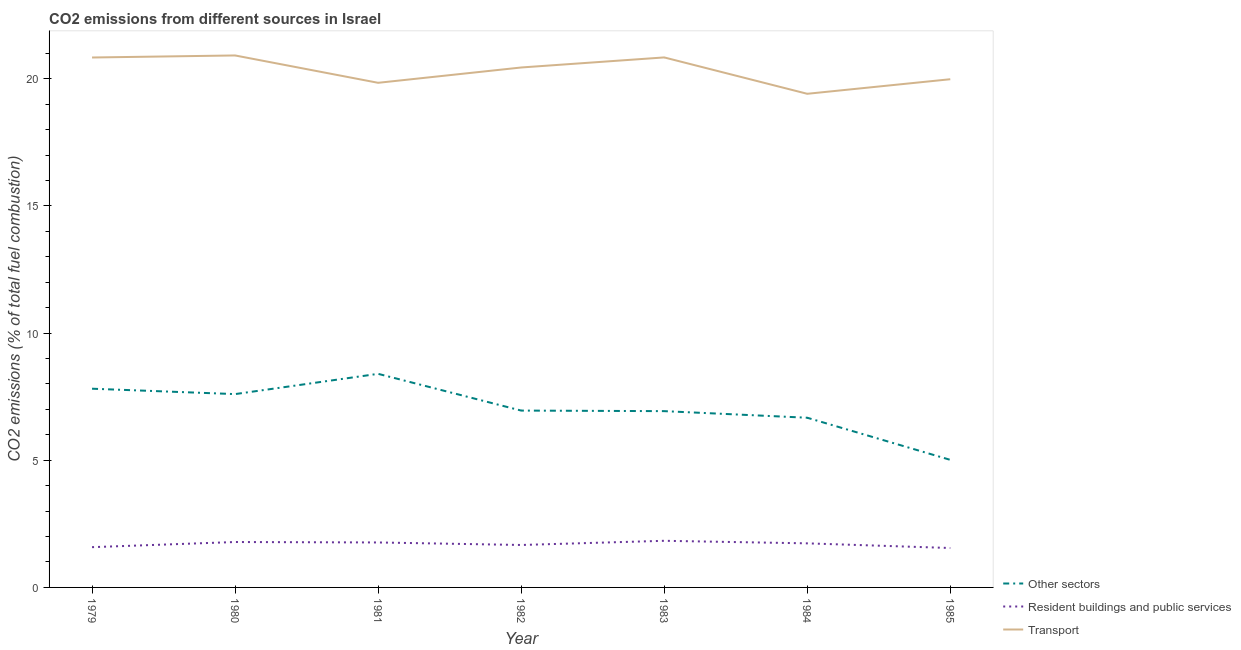Is the number of lines equal to the number of legend labels?
Your answer should be compact. Yes. What is the percentage of co2 emissions from other sectors in 1983?
Make the answer very short. 6.93. Across all years, what is the maximum percentage of co2 emissions from resident buildings and public services?
Your response must be concise. 1.83. Across all years, what is the minimum percentage of co2 emissions from transport?
Your answer should be compact. 19.41. In which year was the percentage of co2 emissions from resident buildings and public services minimum?
Provide a succinct answer. 1985. What is the total percentage of co2 emissions from other sectors in the graph?
Your response must be concise. 49.39. What is the difference between the percentage of co2 emissions from other sectors in 1979 and that in 1983?
Your answer should be very brief. 0.88. What is the difference between the percentage of co2 emissions from other sectors in 1980 and the percentage of co2 emissions from transport in 1983?
Your answer should be compact. -13.24. What is the average percentage of co2 emissions from resident buildings and public services per year?
Offer a terse response. 1.7. In the year 1983, what is the difference between the percentage of co2 emissions from other sectors and percentage of co2 emissions from transport?
Offer a terse response. -13.91. In how many years, is the percentage of co2 emissions from other sectors greater than 16 %?
Your answer should be very brief. 0. What is the ratio of the percentage of co2 emissions from resident buildings and public services in 1982 to that in 1985?
Give a very brief answer. 1.08. What is the difference between the highest and the second highest percentage of co2 emissions from resident buildings and public services?
Give a very brief answer. 0.05. What is the difference between the highest and the lowest percentage of co2 emissions from resident buildings and public services?
Your answer should be compact. 0.28. In how many years, is the percentage of co2 emissions from transport greater than the average percentage of co2 emissions from transport taken over all years?
Keep it short and to the point. 4. Is the sum of the percentage of co2 emissions from other sectors in 1979 and 1982 greater than the maximum percentage of co2 emissions from resident buildings and public services across all years?
Give a very brief answer. Yes. Is the percentage of co2 emissions from other sectors strictly greater than the percentage of co2 emissions from transport over the years?
Your answer should be compact. No. How many years are there in the graph?
Give a very brief answer. 7. Does the graph contain any zero values?
Your answer should be compact. No. Does the graph contain grids?
Make the answer very short. No. How many legend labels are there?
Your answer should be compact. 3. What is the title of the graph?
Provide a short and direct response. CO2 emissions from different sources in Israel. Does "Ores and metals" appear as one of the legend labels in the graph?
Give a very brief answer. No. What is the label or title of the Y-axis?
Your response must be concise. CO2 emissions (% of total fuel combustion). What is the CO2 emissions (% of total fuel combustion) of Other sectors in 1979?
Your answer should be compact. 7.81. What is the CO2 emissions (% of total fuel combustion) of Resident buildings and public services in 1979?
Keep it short and to the point. 1.58. What is the CO2 emissions (% of total fuel combustion) of Transport in 1979?
Give a very brief answer. 20.84. What is the CO2 emissions (% of total fuel combustion) in Other sectors in 1980?
Offer a very short reply. 7.6. What is the CO2 emissions (% of total fuel combustion) of Resident buildings and public services in 1980?
Keep it short and to the point. 1.79. What is the CO2 emissions (% of total fuel combustion) of Transport in 1980?
Your answer should be compact. 20.92. What is the CO2 emissions (% of total fuel combustion) of Other sectors in 1981?
Give a very brief answer. 8.4. What is the CO2 emissions (% of total fuel combustion) in Resident buildings and public services in 1981?
Keep it short and to the point. 1.77. What is the CO2 emissions (% of total fuel combustion) in Transport in 1981?
Your answer should be compact. 19.84. What is the CO2 emissions (% of total fuel combustion) of Other sectors in 1982?
Your answer should be compact. 6.95. What is the CO2 emissions (% of total fuel combustion) in Resident buildings and public services in 1982?
Keep it short and to the point. 1.67. What is the CO2 emissions (% of total fuel combustion) of Transport in 1982?
Your response must be concise. 20.45. What is the CO2 emissions (% of total fuel combustion) in Other sectors in 1983?
Offer a very short reply. 6.93. What is the CO2 emissions (% of total fuel combustion) in Resident buildings and public services in 1983?
Offer a terse response. 1.83. What is the CO2 emissions (% of total fuel combustion) in Transport in 1983?
Ensure brevity in your answer.  20.84. What is the CO2 emissions (% of total fuel combustion) of Other sectors in 1984?
Give a very brief answer. 6.67. What is the CO2 emissions (% of total fuel combustion) of Resident buildings and public services in 1984?
Offer a terse response. 1.73. What is the CO2 emissions (% of total fuel combustion) of Transport in 1984?
Your answer should be very brief. 19.41. What is the CO2 emissions (% of total fuel combustion) in Other sectors in 1985?
Your answer should be compact. 5.02. What is the CO2 emissions (% of total fuel combustion) in Resident buildings and public services in 1985?
Provide a short and direct response. 1.55. What is the CO2 emissions (% of total fuel combustion) in Transport in 1985?
Your answer should be compact. 19.98. Across all years, what is the maximum CO2 emissions (% of total fuel combustion) of Other sectors?
Ensure brevity in your answer.  8.4. Across all years, what is the maximum CO2 emissions (% of total fuel combustion) of Resident buildings and public services?
Your answer should be very brief. 1.83. Across all years, what is the maximum CO2 emissions (% of total fuel combustion) in Transport?
Your response must be concise. 20.92. Across all years, what is the minimum CO2 emissions (% of total fuel combustion) of Other sectors?
Provide a short and direct response. 5.02. Across all years, what is the minimum CO2 emissions (% of total fuel combustion) of Resident buildings and public services?
Offer a very short reply. 1.55. Across all years, what is the minimum CO2 emissions (% of total fuel combustion) in Transport?
Your answer should be very brief. 19.41. What is the total CO2 emissions (% of total fuel combustion) of Other sectors in the graph?
Give a very brief answer. 49.39. What is the total CO2 emissions (% of total fuel combustion) of Resident buildings and public services in the graph?
Your response must be concise. 11.92. What is the total CO2 emissions (% of total fuel combustion) of Transport in the graph?
Provide a short and direct response. 142.28. What is the difference between the CO2 emissions (% of total fuel combustion) of Other sectors in 1979 and that in 1980?
Make the answer very short. 0.21. What is the difference between the CO2 emissions (% of total fuel combustion) of Resident buildings and public services in 1979 and that in 1980?
Offer a very short reply. -0.2. What is the difference between the CO2 emissions (% of total fuel combustion) in Transport in 1979 and that in 1980?
Offer a terse response. -0.08. What is the difference between the CO2 emissions (% of total fuel combustion) of Other sectors in 1979 and that in 1981?
Provide a short and direct response. -0.58. What is the difference between the CO2 emissions (% of total fuel combustion) in Resident buildings and public services in 1979 and that in 1981?
Give a very brief answer. -0.18. What is the difference between the CO2 emissions (% of total fuel combustion) in Transport in 1979 and that in 1981?
Offer a very short reply. 0.99. What is the difference between the CO2 emissions (% of total fuel combustion) in Other sectors in 1979 and that in 1982?
Your answer should be compact. 0.86. What is the difference between the CO2 emissions (% of total fuel combustion) in Resident buildings and public services in 1979 and that in 1982?
Your answer should be very brief. -0.09. What is the difference between the CO2 emissions (% of total fuel combustion) in Transport in 1979 and that in 1982?
Keep it short and to the point. 0.39. What is the difference between the CO2 emissions (% of total fuel combustion) in Other sectors in 1979 and that in 1983?
Your response must be concise. 0.88. What is the difference between the CO2 emissions (% of total fuel combustion) of Resident buildings and public services in 1979 and that in 1983?
Provide a succinct answer. -0.25. What is the difference between the CO2 emissions (% of total fuel combustion) of Transport in 1979 and that in 1983?
Your answer should be very brief. -0. What is the difference between the CO2 emissions (% of total fuel combustion) in Other sectors in 1979 and that in 1984?
Provide a succinct answer. 1.14. What is the difference between the CO2 emissions (% of total fuel combustion) of Resident buildings and public services in 1979 and that in 1984?
Keep it short and to the point. -0.15. What is the difference between the CO2 emissions (% of total fuel combustion) of Transport in 1979 and that in 1984?
Offer a terse response. 1.43. What is the difference between the CO2 emissions (% of total fuel combustion) in Other sectors in 1979 and that in 1985?
Your answer should be very brief. 2.8. What is the difference between the CO2 emissions (% of total fuel combustion) of Resident buildings and public services in 1979 and that in 1985?
Your answer should be compact. 0.03. What is the difference between the CO2 emissions (% of total fuel combustion) in Transport in 1979 and that in 1985?
Provide a short and direct response. 0.85. What is the difference between the CO2 emissions (% of total fuel combustion) of Other sectors in 1980 and that in 1981?
Your answer should be very brief. -0.8. What is the difference between the CO2 emissions (% of total fuel combustion) of Resident buildings and public services in 1980 and that in 1981?
Your answer should be compact. 0.02. What is the difference between the CO2 emissions (% of total fuel combustion) in Transport in 1980 and that in 1981?
Make the answer very short. 1.08. What is the difference between the CO2 emissions (% of total fuel combustion) in Other sectors in 1980 and that in 1982?
Make the answer very short. 0.65. What is the difference between the CO2 emissions (% of total fuel combustion) in Resident buildings and public services in 1980 and that in 1982?
Your response must be concise. 0.12. What is the difference between the CO2 emissions (% of total fuel combustion) of Transport in 1980 and that in 1982?
Offer a very short reply. 0.47. What is the difference between the CO2 emissions (% of total fuel combustion) in Other sectors in 1980 and that in 1983?
Keep it short and to the point. 0.67. What is the difference between the CO2 emissions (% of total fuel combustion) in Resident buildings and public services in 1980 and that in 1983?
Your response must be concise. -0.05. What is the difference between the CO2 emissions (% of total fuel combustion) of Transport in 1980 and that in 1983?
Offer a terse response. 0.08. What is the difference between the CO2 emissions (% of total fuel combustion) in Other sectors in 1980 and that in 1984?
Your answer should be compact. 0.93. What is the difference between the CO2 emissions (% of total fuel combustion) of Resident buildings and public services in 1980 and that in 1984?
Keep it short and to the point. 0.05. What is the difference between the CO2 emissions (% of total fuel combustion) of Transport in 1980 and that in 1984?
Ensure brevity in your answer.  1.51. What is the difference between the CO2 emissions (% of total fuel combustion) of Other sectors in 1980 and that in 1985?
Your answer should be compact. 2.59. What is the difference between the CO2 emissions (% of total fuel combustion) in Resident buildings and public services in 1980 and that in 1985?
Your answer should be very brief. 0.24. What is the difference between the CO2 emissions (% of total fuel combustion) of Transport in 1980 and that in 1985?
Your answer should be very brief. 0.93. What is the difference between the CO2 emissions (% of total fuel combustion) of Other sectors in 1981 and that in 1982?
Make the answer very short. 1.44. What is the difference between the CO2 emissions (% of total fuel combustion) in Resident buildings and public services in 1981 and that in 1982?
Provide a succinct answer. 0.1. What is the difference between the CO2 emissions (% of total fuel combustion) of Transport in 1981 and that in 1982?
Your answer should be very brief. -0.6. What is the difference between the CO2 emissions (% of total fuel combustion) of Other sectors in 1981 and that in 1983?
Ensure brevity in your answer.  1.47. What is the difference between the CO2 emissions (% of total fuel combustion) in Resident buildings and public services in 1981 and that in 1983?
Offer a terse response. -0.07. What is the difference between the CO2 emissions (% of total fuel combustion) in Transport in 1981 and that in 1983?
Make the answer very short. -1. What is the difference between the CO2 emissions (% of total fuel combustion) in Other sectors in 1981 and that in 1984?
Give a very brief answer. 1.73. What is the difference between the CO2 emissions (% of total fuel combustion) in Resident buildings and public services in 1981 and that in 1984?
Your answer should be compact. 0.04. What is the difference between the CO2 emissions (% of total fuel combustion) in Transport in 1981 and that in 1984?
Your answer should be very brief. 0.43. What is the difference between the CO2 emissions (% of total fuel combustion) of Other sectors in 1981 and that in 1985?
Ensure brevity in your answer.  3.38. What is the difference between the CO2 emissions (% of total fuel combustion) of Resident buildings and public services in 1981 and that in 1985?
Your answer should be compact. 0.22. What is the difference between the CO2 emissions (% of total fuel combustion) in Transport in 1981 and that in 1985?
Keep it short and to the point. -0.14. What is the difference between the CO2 emissions (% of total fuel combustion) in Other sectors in 1982 and that in 1983?
Offer a very short reply. 0.02. What is the difference between the CO2 emissions (% of total fuel combustion) in Resident buildings and public services in 1982 and that in 1983?
Offer a terse response. -0.16. What is the difference between the CO2 emissions (% of total fuel combustion) of Transport in 1982 and that in 1983?
Your response must be concise. -0.4. What is the difference between the CO2 emissions (% of total fuel combustion) in Other sectors in 1982 and that in 1984?
Your response must be concise. 0.28. What is the difference between the CO2 emissions (% of total fuel combustion) of Resident buildings and public services in 1982 and that in 1984?
Provide a succinct answer. -0.06. What is the difference between the CO2 emissions (% of total fuel combustion) of Transport in 1982 and that in 1984?
Provide a succinct answer. 1.03. What is the difference between the CO2 emissions (% of total fuel combustion) in Other sectors in 1982 and that in 1985?
Offer a very short reply. 1.94. What is the difference between the CO2 emissions (% of total fuel combustion) in Resident buildings and public services in 1982 and that in 1985?
Your response must be concise. 0.12. What is the difference between the CO2 emissions (% of total fuel combustion) of Transport in 1982 and that in 1985?
Make the answer very short. 0.46. What is the difference between the CO2 emissions (% of total fuel combustion) in Other sectors in 1983 and that in 1984?
Offer a very short reply. 0.26. What is the difference between the CO2 emissions (% of total fuel combustion) in Resident buildings and public services in 1983 and that in 1984?
Give a very brief answer. 0.1. What is the difference between the CO2 emissions (% of total fuel combustion) in Transport in 1983 and that in 1984?
Your response must be concise. 1.43. What is the difference between the CO2 emissions (% of total fuel combustion) in Other sectors in 1983 and that in 1985?
Offer a very short reply. 1.92. What is the difference between the CO2 emissions (% of total fuel combustion) of Resident buildings and public services in 1983 and that in 1985?
Your answer should be very brief. 0.28. What is the difference between the CO2 emissions (% of total fuel combustion) in Transport in 1983 and that in 1985?
Offer a very short reply. 0.86. What is the difference between the CO2 emissions (% of total fuel combustion) in Other sectors in 1984 and that in 1985?
Give a very brief answer. 1.66. What is the difference between the CO2 emissions (% of total fuel combustion) of Resident buildings and public services in 1984 and that in 1985?
Your answer should be compact. 0.18. What is the difference between the CO2 emissions (% of total fuel combustion) in Transport in 1984 and that in 1985?
Provide a succinct answer. -0.57. What is the difference between the CO2 emissions (% of total fuel combustion) of Other sectors in 1979 and the CO2 emissions (% of total fuel combustion) of Resident buildings and public services in 1980?
Your answer should be very brief. 6.03. What is the difference between the CO2 emissions (% of total fuel combustion) of Other sectors in 1979 and the CO2 emissions (% of total fuel combustion) of Transport in 1980?
Make the answer very short. -13.1. What is the difference between the CO2 emissions (% of total fuel combustion) in Resident buildings and public services in 1979 and the CO2 emissions (% of total fuel combustion) in Transport in 1980?
Ensure brevity in your answer.  -19.34. What is the difference between the CO2 emissions (% of total fuel combustion) of Other sectors in 1979 and the CO2 emissions (% of total fuel combustion) of Resident buildings and public services in 1981?
Make the answer very short. 6.05. What is the difference between the CO2 emissions (% of total fuel combustion) of Other sectors in 1979 and the CO2 emissions (% of total fuel combustion) of Transport in 1981?
Ensure brevity in your answer.  -12.03. What is the difference between the CO2 emissions (% of total fuel combustion) of Resident buildings and public services in 1979 and the CO2 emissions (% of total fuel combustion) of Transport in 1981?
Your answer should be compact. -18.26. What is the difference between the CO2 emissions (% of total fuel combustion) of Other sectors in 1979 and the CO2 emissions (% of total fuel combustion) of Resident buildings and public services in 1982?
Provide a short and direct response. 6.15. What is the difference between the CO2 emissions (% of total fuel combustion) of Other sectors in 1979 and the CO2 emissions (% of total fuel combustion) of Transport in 1982?
Offer a terse response. -12.63. What is the difference between the CO2 emissions (% of total fuel combustion) in Resident buildings and public services in 1979 and the CO2 emissions (% of total fuel combustion) in Transport in 1982?
Keep it short and to the point. -18.86. What is the difference between the CO2 emissions (% of total fuel combustion) in Other sectors in 1979 and the CO2 emissions (% of total fuel combustion) in Resident buildings and public services in 1983?
Provide a succinct answer. 5.98. What is the difference between the CO2 emissions (% of total fuel combustion) of Other sectors in 1979 and the CO2 emissions (% of total fuel combustion) of Transport in 1983?
Offer a terse response. -13.03. What is the difference between the CO2 emissions (% of total fuel combustion) in Resident buildings and public services in 1979 and the CO2 emissions (% of total fuel combustion) in Transport in 1983?
Your answer should be very brief. -19.26. What is the difference between the CO2 emissions (% of total fuel combustion) of Other sectors in 1979 and the CO2 emissions (% of total fuel combustion) of Resident buildings and public services in 1984?
Your response must be concise. 6.08. What is the difference between the CO2 emissions (% of total fuel combustion) of Other sectors in 1979 and the CO2 emissions (% of total fuel combustion) of Transport in 1984?
Provide a short and direct response. -11.6. What is the difference between the CO2 emissions (% of total fuel combustion) in Resident buildings and public services in 1979 and the CO2 emissions (% of total fuel combustion) in Transport in 1984?
Provide a short and direct response. -17.83. What is the difference between the CO2 emissions (% of total fuel combustion) of Other sectors in 1979 and the CO2 emissions (% of total fuel combustion) of Resident buildings and public services in 1985?
Your answer should be very brief. 6.26. What is the difference between the CO2 emissions (% of total fuel combustion) in Other sectors in 1979 and the CO2 emissions (% of total fuel combustion) in Transport in 1985?
Keep it short and to the point. -12.17. What is the difference between the CO2 emissions (% of total fuel combustion) in Resident buildings and public services in 1979 and the CO2 emissions (% of total fuel combustion) in Transport in 1985?
Provide a short and direct response. -18.4. What is the difference between the CO2 emissions (% of total fuel combustion) of Other sectors in 1980 and the CO2 emissions (% of total fuel combustion) of Resident buildings and public services in 1981?
Provide a short and direct response. 5.83. What is the difference between the CO2 emissions (% of total fuel combustion) in Other sectors in 1980 and the CO2 emissions (% of total fuel combustion) in Transport in 1981?
Give a very brief answer. -12.24. What is the difference between the CO2 emissions (% of total fuel combustion) in Resident buildings and public services in 1980 and the CO2 emissions (% of total fuel combustion) in Transport in 1981?
Offer a terse response. -18.06. What is the difference between the CO2 emissions (% of total fuel combustion) in Other sectors in 1980 and the CO2 emissions (% of total fuel combustion) in Resident buildings and public services in 1982?
Give a very brief answer. 5.93. What is the difference between the CO2 emissions (% of total fuel combustion) of Other sectors in 1980 and the CO2 emissions (% of total fuel combustion) of Transport in 1982?
Ensure brevity in your answer.  -12.84. What is the difference between the CO2 emissions (% of total fuel combustion) in Resident buildings and public services in 1980 and the CO2 emissions (% of total fuel combustion) in Transport in 1982?
Offer a very short reply. -18.66. What is the difference between the CO2 emissions (% of total fuel combustion) of Other sectors in 1980 and the CO2 emissions (% of total fuel combustion) of Resident buildings and public services in 1983?
Offer a terse response. 5.77. What is the difference between the CO2 emissions (% of total fuel combustion) of Other sectors in 1980 and the CO2 emissions (% of total fuel combustion) of Transport in 1983?
Give a very brief answer. -13.24. What is the difference between the CO2 emissions (% of total fuel combustion) of Resident buildings and public services in 1980 and the CO2 emissions (% of total fuel combustion) of Transport in 1983?
Ensure brevity in your answer.  -19.06. What is the difference between the CO2 emissions (% of total fuel combustion) of Other sectors in 1980 and the CO2 emissions (% of total fuel combustion) of Resident buildings and public services in 1984?
Your response must be concise. 5.87. What is the difference between the CO2 emissions (% of total fuel combustion) of Other sectors in 1980 and the CO2 emissions (% of total fuel combustion) of Transport in 1984?
Keep it short and to the point. -11.81. What is the difference between the CO2 emissions (% of total fuel combustion) in Resident buildings and public services in 1980 and the CO2 emissions (% of total fuel combustion) in Transport in 1984?
Ensure brevity in your answer.  -17.62. What is the difference between the CO2 emissions (% of total fuel combustion) in Other sectors in 1980 and the CO2 emissions (% of total fuel combustion) in Resident buildings and public services in 1985?
Offer a terse response. 6.05. What is the difference between the CO2 emissions (% of total fuel combustion) of Other sectors in 1980 and the CO2 emissions (% of total fuel combustion) of Transport in 1985?
Your answer should be very brief. -12.38. What is the difference between the CO2 emissions (% of total fuel combustion) in Resident buildings and public services in 1980 and the CO2 emissions (% of total fuel combustion) in Transport in 1985?
Provide a short and direct response. -18.2. What is the difference between the CO2 emissions (% of total fuel combustion) of Other sectors in 1981 and the CO2 emissions (% of total fuel combustion) of Resident buildings and public services in 1982?
Make the answer very short. 6.73. What is the difference between the CO2 emissions (% of total fuel combustion) in Other sectors in 1981 and the CO2 emissions (% of total fuel combustion) in Transport in 1982?
Provide a succinct answer. -12.05. What is the difference between the CO2 emissions (% of total fuel combustion) of Resident buildings and public services in 1981 and the CO2 emissions (% of total fuel combustion) of Transport in 1982?
Provide a short and direct response. -18.68. What is the difference between the CO2 emissions (% of total fuel combustion) in Other sectors in 1981 and the CO2 emissions (% of total fuel combustion) in Resident buildings and public services in 1983?
Your response must be concise. 6.57. What is the difference between the CO2 emissions (% of total fuel combustion) of Other sectors in 1981 and the CO2 emissions (% of total fuel combustion) of Transport in 1983?
Your response must be concise. -12.44. What is the difference between the CO2 emissions (% of total fuel combustion) of Resident buildings and public services in 1981 and the CO2 emissions (% of total fuel combustion) of Transport in 1983?
Provide a succinct answer. -19.07. What is the difference between the CO2 emissions (% of total fuel combustion) of Other sectors in 1981 and the CO2 emissions (% of total fuel combustion) of Resident buildings and public services in 1984?
Keep it short and to the point. 6.67. What is the difference between the CO2 emissions (% of total fuel combustion) of Other sectors in 1981 and the CO2 emissions (% of total fuel combustion) of Transport in 1984?
Your answer should be very brief. -11.01. What is the difference between the CO2 emissions (% of total fuel combustion) in Resident buildings and public services in 1981 and the CO2 emissions (% of total fuel combustion) in Transport in 1984?
Offer a terse response. -17.64. What is the difference between the CO2 emissions (% of total fuel combustion) in Other sectors in 1981 and the CO2 emissions (% of total fuel combustion) in Resident buildings and public services in 1985?
Your answer should be compact. 6.85. What is the difference between the CO2 emissions (% of total fuel combustion) in Other sectors in 1981 and the CO2 emissions (% of total fuel combustion) in Transport in 1985?
Your response must be concise. -11.58. What is the difference between the CO2 emissions (% of total fuel combustion) of Resident buildings and public services in 1981 and the CO2 emissions (% of total fuel combustion) of Transport in 1985?
Your answer should be compact. -18.22. What is the difference between the CO2 emissions (% of total fuel combustion) of Other sectors in 1982 and the CO2 emissions (% of total fuel combustion) of Resident buildings and public services in 1983?
Make the answer very short. 5.12. What is the difference between the CO2 emissions (% of total fuel combustion) of Other sectors in 1982 and the CO2 emissions (% of total fuel combustion) of Transport in 1983?
Ensure brevity in your answer.  -13.89. What is the difference between the CO2 emissions (% of total fuel combustion) in Resident buildings and public services in 1982 and the CO2 emissions (% of total fuel combustion) in Transport in 1983?
Keep it short and to the point. -19.17. What is the difference between the CO2 emissions (% of total fuel combustion) of Other sectors in 1982 and the CO2 emissions (% of total fuel combustion) of Resident buildings and public services in 1984?
Provide a short and direct response. 5.22. What is the difference between the CO2 emissions (% of total fuel combustion) in Other sectors in 1982 and the CO2 emissions (% of total fuel combustion) in Transport in 1984?
Your answer should be compact. -12.46. What is the difference between the CO2 emissions (% of total fuel combustion) of Resident buildings and public services in 1982 and the CO2 emissions (% of total fuel combustion) of Transport in 1984?
Your answer should be very brief. -17.74. What is the difference between the CO2 emissions (% of total fuel combustion) in Other sectors in 1982 and the CO2 emissions (% of total fuel combustion) in Resident buildings and public services in 1985?
Offer a terse response. 5.4. What is the difference between the CO2 emissions (% of total fuel combustion) of Other sectors in 1982 and the CO2 emissions (% of total fuel combustion) of Transport in 1985?
Offer a terse response. -13.03. What is the difference between the CO2 emissions (% of total fuel combustion) in Resident buildings and public services in 1982 and the CO2 emissions (% of total fuel combustion) in Transport in 1985?
Your answer should be compact. -18.31. What is the difference between the CO2 emissions (% of total fuel combustion) in Other sectors in 1983 and the CO2 emissions (% of total fuel combustion) in Resident buildings and public services in 1984?
Your answer should be very brief. 5.2. What is the difference between the CO2 emissions (% of total fuel combustion) of Other sectors in 1983 and the CO2 emissions (% of total fuel combustion) of Transport in 1984?
Your answer should be compact. -12.48. What is the difference between the CO2 emissions (% of total fuel combustion) of Resident buildings and public services in 1983 and the CO2 emissions (% of total fuel combustion) of Transport in 1984?
Make the answer very short. -17.58. What is the difference between the CO2 emissions (% of total fuel combustion) of Other sectors in 1983 and the CO2 emissions (% of total fuel combustion) of Resident buildings and public services in 1985?
Keep it short and to the point. 5.38. What is the difference between the CO2 emissions (% of total fuel combustion) in Other sectors in 1983 and the CO2 emissions (% of total fuel combustion) in Transport in 1985?
Your answer should be compact. -13.05. What is the difference between the CO2 emissions (% of total fuel combustion) in Resident buildings and public services in 1983 and the CO2 emissions (% of total fuel combustion) in Transport in 1985?
Offer a very short reply. -18.15. What is the difference between the CO2 emissions (% of total fuel combustion) in Other sectors in 1984 and the CO2 emissions (% of total fuel combustion) in Resident buildings and public services in 1985?
Give a very brief answer. 5.12. What is the difference between the CO2 emissions (% of total fuel combustion) in Other sectors in 1984 and the CO2 emissions (% of total fuel combustion) in Transport in 1985?
Your response must be concise. -13.31. What is the difference between the CO2 emissions (% of total fuel combustion) of Resident buildings and public services in 1984 and the CO2 emissions (% of total fuel combustion) of Transport in 1985?
Provide a short and direct response. -18.25. What is the average CO2 emissions (% of total fuel combustion) in Other sectors per year?
Offer a very short reply. 7.06. What is the average CO2 emissions (% of total fuel combustion) in Resident buildings and public services per year?
Keep it short and to the point. 1.7. What is the average CO2 emissions (% of total fuel combustion) of Transport per year?
Make the answer very short. 20.33. In the year 1979, what is the difference between the CO2 emissions (% of total fuel combustion) in Other sectors and CO2 emissions (% of total fuel combustion) in Resident buildings and public services?
Ensure brevity in your answer.  6.23. In the year 1979, what is the difference between the CO2 emissions (% of total fuel combustion) in Other sectors and CO2 emissions (% of total fuel combustion) in Transport?
Make the answer very short. -13.02. In the year 1979, what is the difference between the CO2 emissions (% of total fuel combustion) of Resident buildings and public services and CO2 emissions (% of total fuel combustion) of Transport?
Your answer should be very brief. -19.25. In the year 1980, what is the difference between the CO2 emissions (% of total fuel combustion) in Other sectors and CO2 emissions (% of total fuel combustion) in Resident buildings and public services?
Keep it short and to the point. 5.82. In the year 1980, what is the difference between the CO2 emissions (% of total fuel combustion) in Other sectors and CO2 emissions (% of total fuel combustion) in Transport?
Provide a succinct answer. -13.32. In the year 1980, what is the difference between the CO2 emissions (% of total fuel combustion) in Resident buildings and public services and CO2 emissions (% of total fuel combustion) in Transport?
Your response must be concise. -19.13. In the year 1981, what is the difference between the CO2 emissions (% of total fuel combustion) of Other sectors and CO2 emissions (% of total fuel combustion) of Resident buildings and public services?
Ensure brevity in your answer.  6.63. In the year 1981, what is the difference between the CO2 emissions (% of total fuel combustion) of Other sectors and CO2 emissions (% of total fuel combustion) of Transport?
Offer a very short reply. -11.44. In the year 1981, what is the difference between the CO2 emissions (% of total fuel combustion) of Resident buildings and public services and CO2 emissions (% of total fuel combustion) of Transport?
Provide a succinct answer. -18.07. In the year 1982, what is the difference between the CO2 emissions (% of total fuel combustion) of Other sectors and CO2 emissions (% of total fuel combustion) of Resident buildings and public services?
Your answer should be very brief. 5.29. In the year 1982, what is the difference between the CO2 emissions (% of total fuel combustion) in Other sectors and CO2 emissions (% of total fuel combustion) in Transport?
Your response must be concise. -13.49. In the year 1982, what is the difference between the CO2 emissions (% of total fuel combustion) of Resident buildings and public services and CO2 emissions (% of total fuel combustion) of Transport?
Provide a succinct answer. -18.78. In the year 1983, what is the difference between the CO2 emissions (% of total fuel combustion) in Other sectors and CO2 emissions (% of total fuel combustion) in Resident buildings and public services?
Give a very brief answer. 5.1. In the year 1983, what is the difference between the CO2 emissions (% of total fuel combustion) in Other sectors and CO2 emissions (% of total fuel combustion) in Transport?
Ensure brevity in your answer.  -13.91. In the year 1983, what is the difference between the CO2 emissions (% of total fuel combustion) in Resident buildings and public services and CO2 emissions (% of total fuel combustion) in Transport?
Make the answer very short. -19.01. In the year 1984, what is the difference between the CO2 emissions (% of total fuel combustion) in Other sectors and CO2 emissions (% of total fuel combustion) in Resident buildings and public services?
Make the answer very short. 4.94. In the year 1984, what is the difference between the CO2 emissions (% of total fuel combustion) in Other sectors and CO2 emissions (% of total fuel combustion) in Transport?
Offer a very short reply. -12.74. In the year 1984, what is the difference between the CO2 emissions (% of total fuel combustion) of Resident buildings and public services and CO2 emissions (% of total fuel combustion) of Transport?
Provide a succinct answer. -17.68. In the year 1985, what is the difference between the CO2 emissions (% of total fuel combustion) of Other sectors and CO2 emissions (% of total fuel combustion) of Resident buildings and public services?
Provide a short and direct response. 3.47. In the year 1985, what is the difference between the CO2 emissions (% of total fuel combustion) in Other sectors and CO2 emissions (% of total fuel combustion) in Transport?
Provide a short and direct response. -14.97. In the year 1985, what is the difference between the CO2 emissions (% of total fuel combustion) of Resident buildings and public services and CO2 emissions (% of total fuel combustion) of Transport?
Ensure brevity in your answer.  -18.43. What is the ratio of the CO2 emissions (% of total fuel combustion) in Other sectors in 1979 to that in 1980?
Offer a very short reply. 1.03. What is the ratio of the CO2 emissions (% of total fuel combustion) in Resident buildings and public services in 1979 to that in 1980?
Offer a very short reply. 0.89. What is the ratio of the CO2 emissions (% of total fuel combustion) of Transport in 1979 to that in 1980?
Make the answer very short. 1. What is the ratio of the CO2 emissions (% of total fuel combustion) of Other sectors in 1979 to that in 1981?
Your response must be concise. 0.93. What is the ratio of the CO2 emissions (% of total fuel combustion) of Resident buildings and public services in 1979 to that in 1981?
Keep it short and to the point. 0.9. What is the ratio of the CO2 emissions (% of total fuel combustion) in Transport in 1979 to that in 1981?
Offer a very short reply. 1.05. What is the ratio of the CO2 emissions (% of total fuel combustion) of Other sectors in 1979 to that in 1982?
Offer a very short reply. 1.12. What is the ratio of the CO2 emissions (% of total fuel combustion) of Resident buildings and public services in 1979 to that in 1982?
Make the answer very short. 0.95. What is the ratio of the CO2 emissions (% of total fuel combustion) of Transport in 1979 to that in 1982?
Keep it short and to the point. 1.02. What is the ratio of the CO2 emissions (% of total fuel combustion) in Other sectors in 1979 to that in 1983?
Make the answer very short. 1.13. What is the ratio of the CO2 emissions (% of total fuel combustion) of Resident buildings and public services in 1979 to that in 1983?
Offer a terse response. 0.86. What is the ratio of the CO2 emissions (% of total fuel combustion) of Other sectors in 1979 to that in 1984?
Provide a succinct answer. 1.17. What is the ratio of the CO2 emissions (% of total fuel combustion) of Resident buildings and public services in 1979 to that in 1984?
Give a very brief answer. 0.91. What is the ratio of the CO2 emissions (% of total fuel combustion) in Transport in 1979 to that in 1984?
Offer a terse response. 1.07. What is the ratio of the CO2 emissions (% of total fuel combustion) of Other sectors in 1979 to that in 1985?
Offer a very short reply. 1.56. What is the ratio of the CO2 emissions (% of total fuel combustion) in Resident buildings and public services in 1979 to that in 1985?
Provide a short and direct response. 1.02. What is the ratio of the CO2 emissions (% of total fuel combustion) of Transport in 1979 to that in 1985?
Give a very brief answer. 1.04. What is the ratio of the CO2 emissions (% of total fuel combustion) in Other sectors in 1980 to that in 1981?
Ensure brevity in your answer.  0.91. What is the ratio of the CO2 emissions (% of total fuel combustion) in Resident buildings and public services in 1980 to that in 1981?
Give a very brief answer. 1.01. What is the ratio of the CO2 emissions (% of total fuel combustion) in Transport in 1980 to that in 1981?
Offer a very short reply. 1.05. What is the ratio of the CO2 emissions (% of total fuel combustion) of Other sectors in 1980 to that in 1982?
Give a very brief answer. 1.09. What is the ratio of the CO2 emissions (% of total fuel combustion) in Resident buildings and public services in 1980 to that in 1982?
Your answer should be compact. 1.07. What is the ratio of the CO2 emissions (% of total fuel combustion) of Transport in 1980 to that in 1982?
Your answer should be compact. 1.02. What is the ratio of the CO2 emissions (% of total fuel combustion) in Other sectors in 1980 to that in 1983?
Keep it short and to the point. 1.1. What is the ratio of the CO2 emissions (% of total fuel combustion) of Resident buildings and public services in 1980 to that in 1983?
Offer a terse response. 0.97. What is the ratio of the CO2 emissions (% of total fuel combustion) of Other sectors in 1980 to that in 1984?
Offer a very short reply. 1.14. What is the ratio of the CO2 emissions (% of total fuel combustion) in Resident buildings and public services in 1980 to that in 1984?
Your response must be concise. 1.03. What is the ratio of the CO2 emissions (% of total fuel combustion) of Transport in 1980 to that in 1984?
Keep it short and to the point. 1.08. What is the ratio of the CO2 emissions (% of total fuel combustion) in Other sectors in 1980 to that in 1985?
Provide a short and direct response. 1.52. What is the ratio of the CO2 emissions (% of total fuel combustion) of Resident buildings and public services in 1980 to that in 1985?
Make the answer very short. 1.15. What is the ratio of the CO2 emissions (% of total fuel combustion) in Transport in 1980 to that in 1985?
Your answer should be very brief. 1.05. What is the ratio of the CO2 emissions (% of total fuel combustion) in Other sectors in 1981 to that in 1982?
Your response must be concise. 1.21. What is the ratio of the CO2 emissions (% of total fuel combustion) in Resident buildings and public services in 1981 to that in 1982?
Make the answer very short. 1.06. What is the ratio of the CO2 emissions (% of total fuel combustion) in Transport in 1981 to that in 1982?
Keep it short and to the point. 0.97. What is the ratio of the CO2 emissions (% of total fuel combustion) of Other sectors in 1981 to that in 1983?
Ensure brevity in your answer.  1.21. What is the ratio of the CO2 emissions (% of total fuel combustion) of Resident buildings and public services in 1981 to that in 1983?
Offer a terse response. 0.96. What is the ratio of the CO2 emissions (% of total fuel combustion) of Transport in 1981 to that in 1983?
Ensure brevity in your answer.  0.95. What is the ratio of the CO2 emissions (% of total fuel combustion) in Other sectors in 1981 to that in 1984?
Your answer should be compact. 1.26. What is the ratio of the CO2 emissions (% of total fuel combustion) of Resident buildings and public services in 1981 to that in 1984?
Provide a short and direct response. 1.02. What is the ratio of the CO2 emissions (% of total fuel combustion) in Transport in 1981 to that in 1984?
Ensure brevity in your answer.  1.02. What is the ratio of the CO2 emissions (% of total fuel combustion) of Other sectors in 1981 to that in 1985?
Offer a very short reply. 1.67. What is the ratio of the CO2 emissions (% of total fuel combustion) in Resident buildings and public services in 1981 to that in 1985?
Give a very brief answer. 1.14. What is the ratio of the CO2 emissions (% of total fuel combustion) in Transport in 1981 to that in 1985?
Offer a very short reply. 0.99. What is the ratio of the CO2 emissions (% of total fuel combustion) of Resident buildings and public services in 1982 to that in 1983?
Offer a very short reply. 0.91. What is the ratio of the CO2 emissions (% of total fuel combustion) in Transport in 1982 to that in 1983?
Provide a short and direct response. 0.98. What is the ratio of the CO2 emissions (% of total fuel combustion) of Other sectors in 1982 to that in 1984?
Your answer should be compact. 1.04. What is the ratio of the CO2 emissions (% of total fuel combustion) of Resident buildings and public services in 1982 to that in 1984?
Your answer should be very brief. 0.96. What is the ratio of the CO2 emissions (% of total fuel combustion) in Transport in 1982 to that in 1984?
Provide a short and direct response. 1.05. What is the ratio of the CO2 emissions (% of total fuel combustion) in Other sectors in 1982 to that in 1985?
Make the answer very short. 1.39. What is the ratio of the CO2 emissions (% of total fuel combustion) of Transport in 1982 to that in 1985?
Your answer should be compact. 1.02. What is the ratio of the CO2 emissions (% of total fuel combustion) in Other sectors in 1983 to that in 1984?
Offer a very short reply. 1.04. What is the ratio of the CO2 emissions (% of total fuel combustion) in Resident buildings and public services in 1983 to that in 1984?
Provide a short and direct response. 1.06. What is the ratio of the CO2 emissions (% of total fuel combustion) of Transport in 1983 to that in 1984?
Offer a terse response. 1.07. What is the ratio of the CO2 emissions (% of total fuel combustion) of Other sectors in 1983 to that in 1985?
Keep it short and to the point. 1.38. What is the ratio of the CO2 emissions (% of total fuel combustion) in Resident buildings and public services in 1983 to that in 1985?
Your answer should be compact. 1.18. What is the ratio of the CO2 emissions (% of total fuel combustion) in Transport in 1983 to that in 1985?
Offer a very short reply. 1.04. What is the ratio of the CO2 emissions (% of total fuel combustion) in Other sectors in 1984 to that in 1985?
Ensure brevity in your answer.  1.33. What is the ratio of the CO2 emissions (% of total fuel combustion) of Resident buildings and public services in 1984 to that in 1985?
Provide a succinct answer. 1.12. What is the ratio of the CO2 emissions (% of total fuel combustion) of Transport in 1984 to that in 1985?
Your response must be concise. 0.97. What is the difference between the highest and the second highest CO2 emissions (% of total fuel combustion) in Other sectors?
Offer a very short reply. 0.58. What is the difference between the highest and the second highest CO2 emissions (% of total fuel combustion) in Resident buildings and public services?
Keep it short and to the point. 0.05. What is the difference between the highest and the second highest CO2 emissions (% of total fuel combustion) of Transport?
Give a very brief answer. 0.08. What is the difference between the highest and the lowest CO2 emissions (% of total fuel combustion) in Other sectors?
Ensure brevity in your answer.  3.38. What is the difference between the highest and the lowest CO2 emissions (% of total fuel combustion) of Resident buildings and public services?
Keep it short and to the point. 0.28. What is the difference between the highest and the lowest CO2 emissions (% of total fuel combustion) of Transport?
Ensure brevity in your answer.  1.51. 